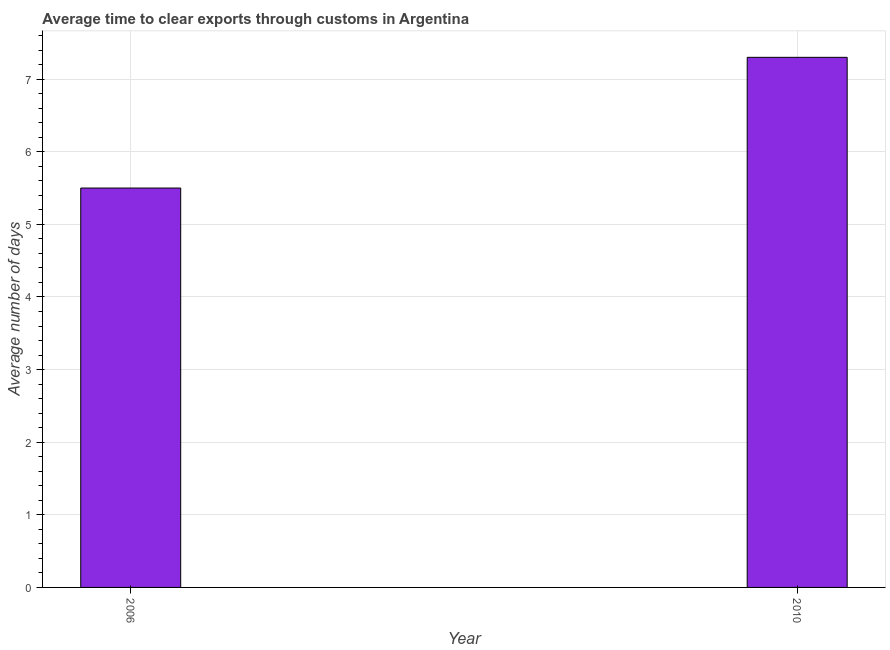Does the graph contain any zero values?
Make the answer very short. No. What is the title of the graph?
Make the answer very short. Average time to clear exports through customs in Argentina. What is the label or title of the X-axis?
Provide a succinct answer. Year. What is the label or title of the Y-axis?
Your answer should be compact. Average number of days. What is the time to clear exports through customs in 2010?
Provide a succinct answer. 7.3. Across all years, what is the maximum time to clear exports through customs?
Your response must be concise. 7.3. Across all years, what is the minimum time to clear exports through customs?
Keep it short and to the point. 5.5. In which year was the time to clear exports through customs maximum?
Ensure brevity in your answer.  2010. In which year was the time to clear exports through customs minimum?
Provide a short and direct response. 2006. What is the sum of the time to clear exports through customs?
Make the answer very short. 12.8. What is the difference between the time to clear exports through customs in 2006 and 2010?
Ensure brevity in your answer.  -1.8. What is the average time to clear exports through customs per year?
Provide a succinct answer. 6.4. In how many years, is the time to clear exports through customs greater than 1.8 days?
Your answer should be very brief. 2. What is the ratio of the time to clear exports through customs in 2006 to that in 2010?
Offer a very short reply. 0.75. How many bars are there?
Give a very brief answer. 2. Are all the bars in the graph horizontal?
Your answer should be very brief. No. How many years are there in the graph?
Provide a succinct answer. 2. What is the Average number of days in 2006?
Your response must be concise. 5.5. What is the Average number of days of 2010?
Offer a terse response. 7.3. What is the ratio of the Average number of days in 2006 to that in 2010?
Provide a short and direct response. 0.75. 